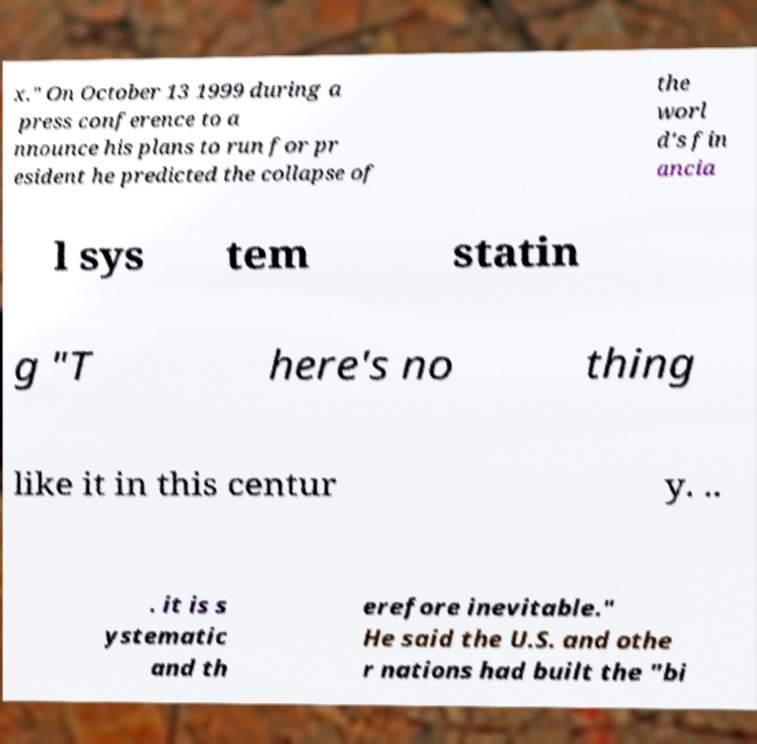Please identify and transcribe the text found in this image. x." On October 13 1999 during a press conference to a nnounce his plans to run for pr esident he predicted the collapse of the worl d's fin ancia l sys tem statin g "T here's no thing like it in this centur y. .. . it is s ystematic and th erefore inevitable." He said the U.S. and othe r nations had built the "bi 